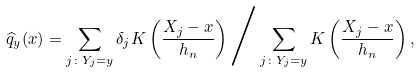Convert formula to latex. <formula><loc_0><loc_0><loc_500><loc_500>\widehat { q } _ { y } ( x ) = \sum _ { j \colon Y _ { j } = y } \delta _ { j } K \left ( \frac { X _ { j } - x } { h _ { n } } \right ) \Big / \sum _ { j \colon Y _ { j } = y } K \left ( \frac { X _ { j } - x } { h _ { n } } \right ) ,</formula> 